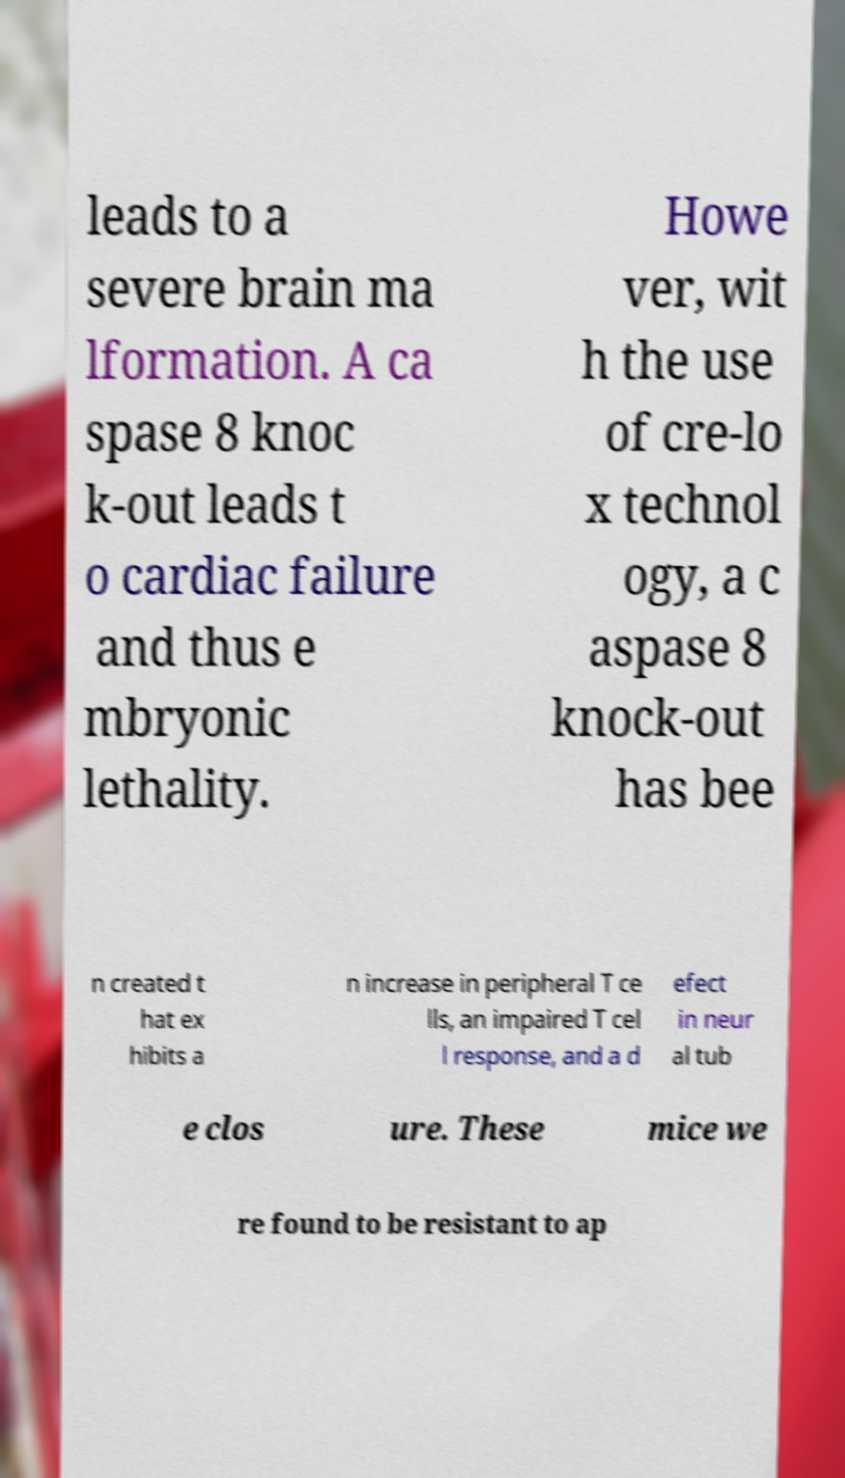Can you accurately transcribe the text from the provided image for me? leads to a severe brain ma lformation. A ca spase 8 knoc k-out leads t o cardiac failure and thus e mbryonic lethality. Howe ver, wit h the use of cre-lo x technol ogy, a c aspase 8 knock-out has bee n created t hat ex hibits a n increase in peripheral T ce lls, an impaired T cel l response, and a d efect in neur al tub e clos ure. These mice we re found to be resistant to ap 